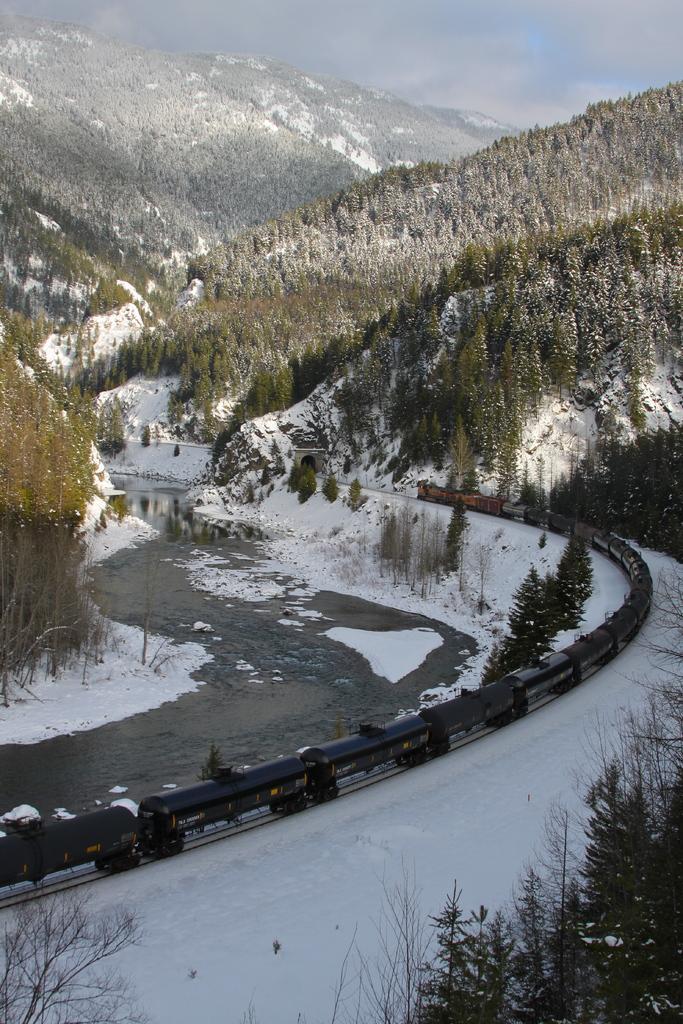Describe this image in one or two sentences. In this picture we can see the train. We can see a few plants in the bottom left and right side. There is the snow. We can see the water. There are a few trees and mountains in the background. Sky is cloudy. 